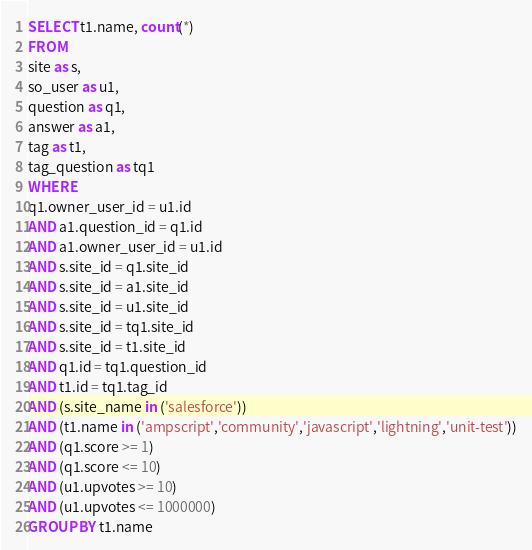<code> <loc_0><loc_0><loc_500><loc_500><_SQL_>SELECT t1.name, count(*)
FROM
site as s,
so_user as u1,
question as q1,
answer as a1,
tag as t1,
tag_question as tq1
WHERE
q1.owner_user_id = u1.id
AND a1.question_id = q1.id
AND a1.owner_user_id = u1.id
AND s.site_id = q1.site_id
AND s.site_id = a1.site_id
AND s.site_id = u1.site_id
AND s.site_id = tq1.site_id
AND s.site_id = t1.site_id
AND q1.id = tq1.question_id
AND t1.id = tq1.tag_id
AND (s.site_name in ('salesforce'))
AND (t1.name in ('ampscript','community','javascript','lightning','unit-test'))
AND (q1.score >= 1)
AND (q1.score <= 10)
AND (u1.upvotes >= 10)
AND (u1.upvotes <= 1000000)
GROUP BY t1.name</code> 